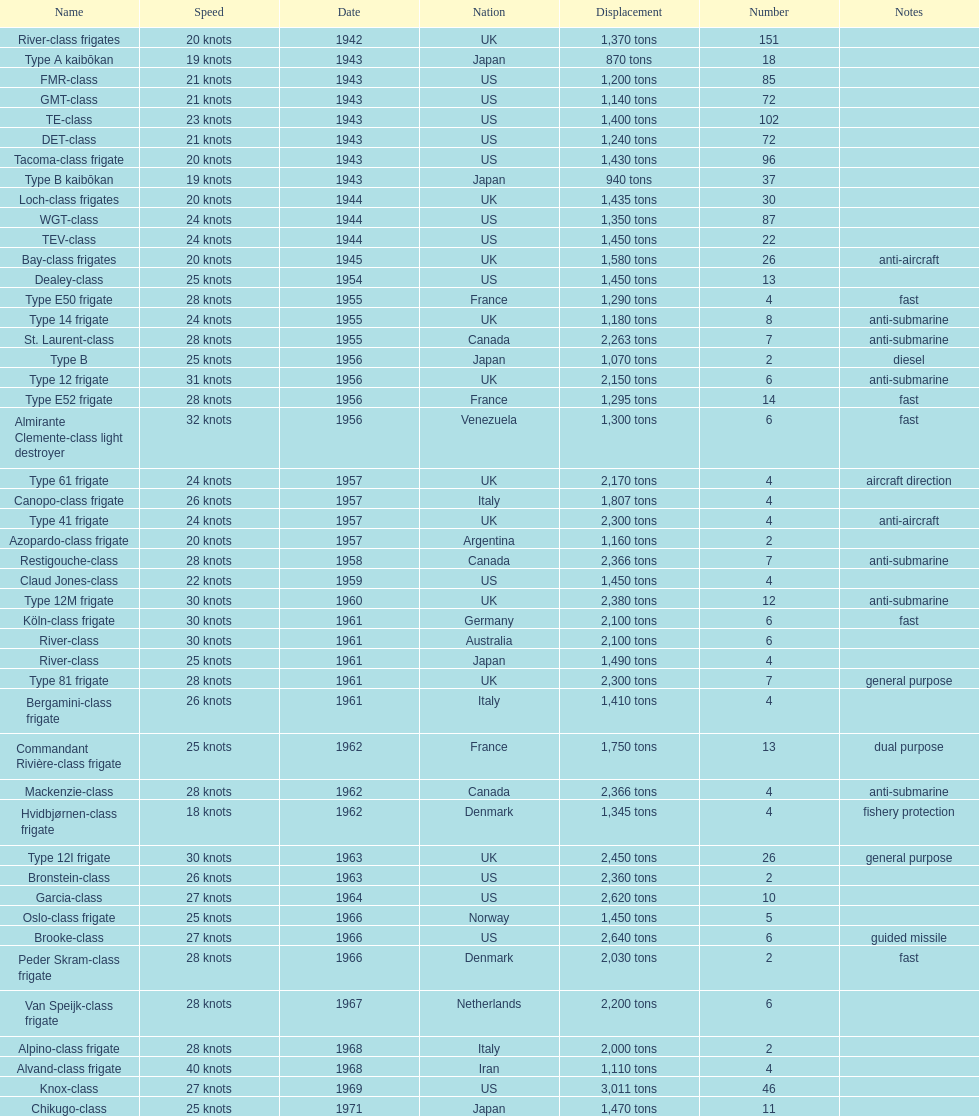How many tons does the te-class displace? 1,400 tons. 